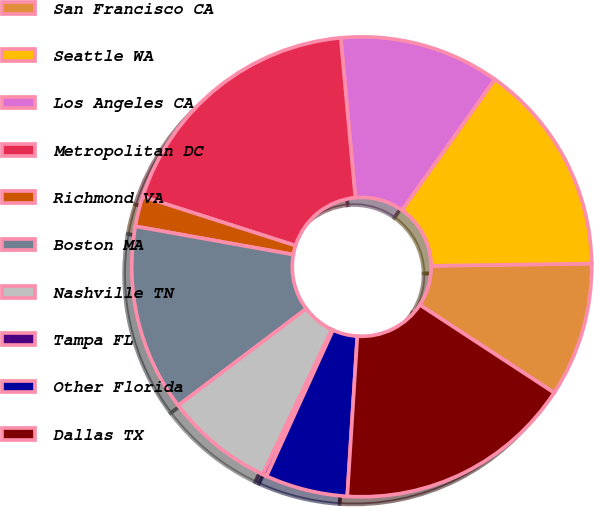Convert chart. <chart><loc_0><loc_0><loc_500><loc_500><pie_chart><fcel>San Francisco CA<fcel>Seattle WA<fcel>Los Angeles CA<fcel>Metropolitan DC<fcel>Richmond VA<fcel>Boston MA<fcel>Nashville TN<fcel>Tampa FL<fcel>Other Florida<fcel>Dallas TX<nl><fcel>9.45%<fcel>14.95%<fcel>11.28%<fcel>18.61%<fcel>2.12%<fcel>13.12%<fcel>7.62%<fcel>0.29%<fcel>5.79%<fcel>16.78%<nl></chart> 